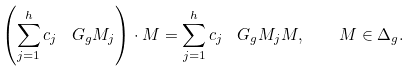<formula> <loc_0><loc_0><loc_500><loc_500>\left ( \sum _ { j = 1 } ^ { h } c _ { j } \, \ G _ { g } M _ { j } \right ) \cdot M = \sum _ { j = 1 } ^ { h } c _ { j } \, \ G _ { g } M _ { j } M , \quad M \in \Delta _ { g } .</formula> 